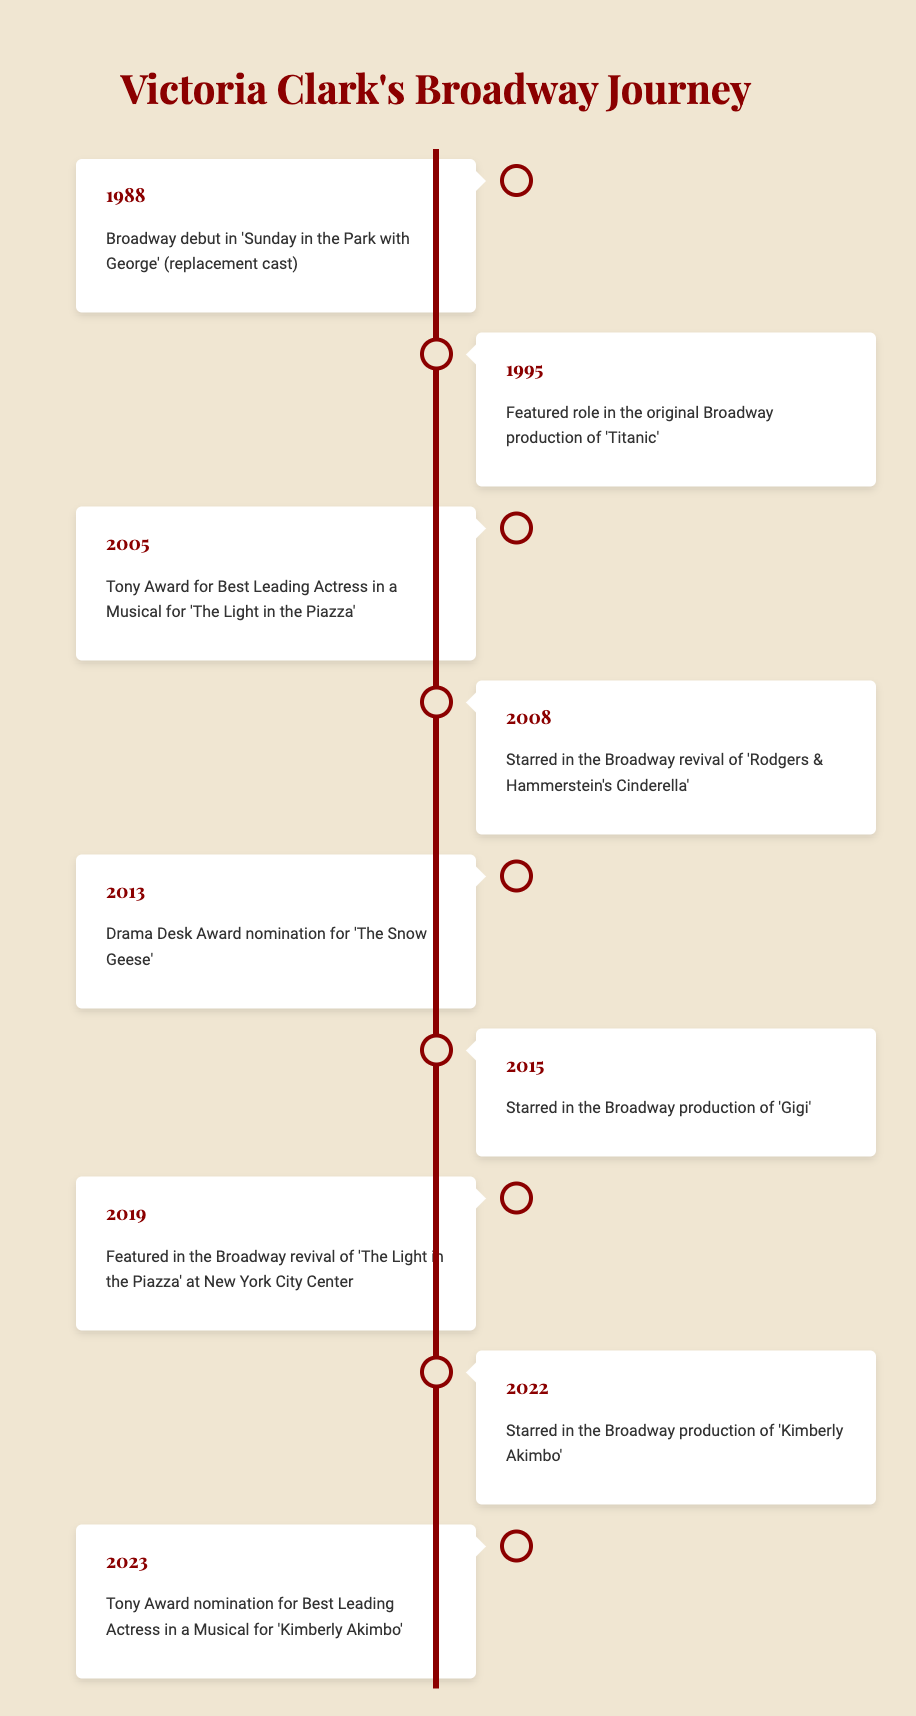What year did Victoria Clark make her Broadway debut? According to the timeline, Victoria Clark made her Broadway debut in the year 1988.
Answer: 1988 Which musical earned Victoria Clark a Tony Award? The timeline indicates that Victoria Clark won a Tony Award for Best Leading Actress in a Musical in 2005 for 'The Light in the Piazza'.
Answer: 'The Light in the Piazza' Did Victoria Clark star in 'Gigi' on Broadway? Yes, the timeline records that she starred in the Broadway production of 'Gigi' in 2015.
Answer: Yes How many years passed between Victoria Clark’s Broadway debut and her Tony Award win? Victoria Clark’s Broadway debut was in 1988 and her Tony Award win was in 2005. The difference in years is 2005 - 1988 = 17 years.
Answer: 17 years What award nomination did Victoria Clark receive in 2023? According to the timeline, in 2023, Victoria Clark received a Tony Award nomination for Best Leading Actress in a Musical for 'Kimberly Akimbo'.
Answer: Tony Award nomination for Best Leading Actress in a Musical Which productions did Victoria Clark star in that involved the musical 'The Light in the Piazza'? The timeline shows that she starred in the original production of 'The Light in the Piazza' and was featured in its revival at New York City Center in 2019.
Answer: 'The Light in the Piazza' (original and revival) Was Victoria Clark nominated for a Drama Desk Award? Yes, the timeline notes that she was nominated for a Drama Desk Award for her performance in 'The Snow Geese' in 2013.
Answer: Yes What is the total number of distinct Broadway productions mentioned in the timeline? The timeline lists six distinct Broadway productions: 'Sunday in the Park with George', 'Titanic', 'The Light in the Piazza', 'Rodgers & Hammerstein's Cinderella', 'Gigi', and 'Kimberly Akimbo'. Therefore, the total is 6.
Answer: 6 productions In which year did Victoria Clark star in the Broadway revival of 'Rodgers & Hammerstein's Cinderella'? The timeline indicates that Victoria Clark starred in the Broadway revival of 'Rodgers & Hammerstein's Cinderella' in 2008.
Answer: 2008 